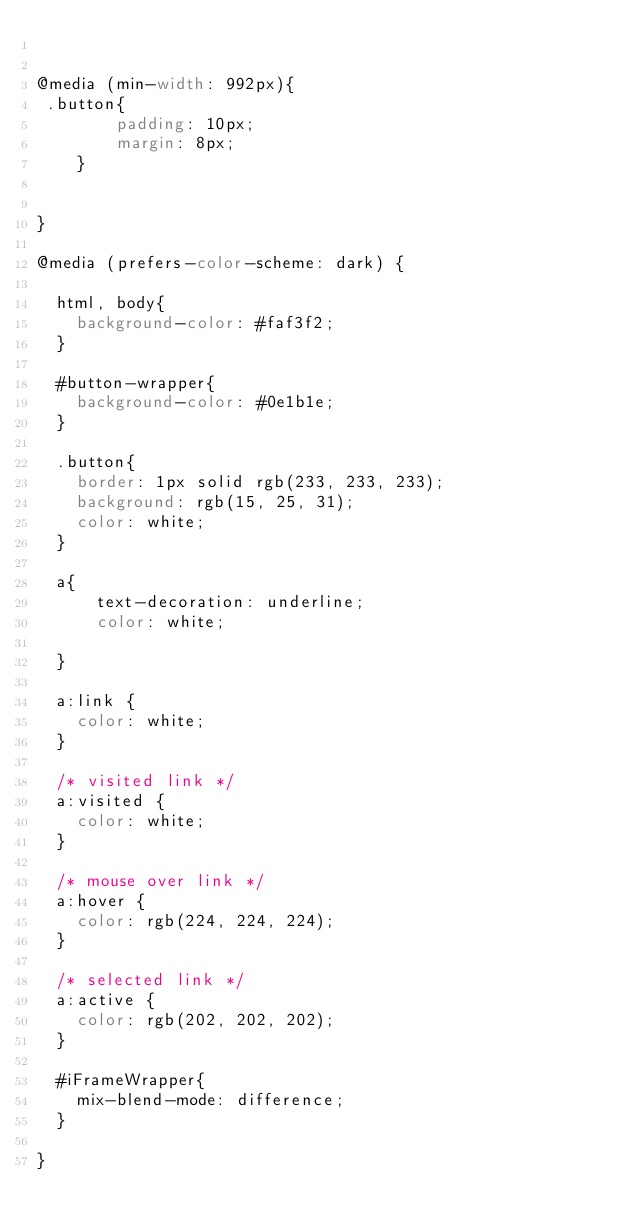<code> <loc_0><loc_0><loc_500><loc_500><_CSS_>

@media (min-width: 992px){
 .button{
		padding: 10px;
		margin: 8px;
	}


}

@media (prefers-color-scheme: dark) {

  html, body{
    background-color: #faf3f2;
  }

  #button-wrapper{
    background-color: #0e1b1e;
  }

  .button{
    border: 1px solid rgb(233, 233, 233);
    background: rgb(15, 25, 31);
	color: white;
  }

  a{
      text-decoration: underline;
	  color: white;

  }

  a:link {
    color: white;
  }

  /* visited link */
  a:visited {
    color: white;
  }

  /* mouse over link */
  a:hover {
    color: rgb(224, 224, 224);
  }

  /* selected link */
  a:active {
    color: rgb(202, 202, 202);
  }

  #iFrameWrapper{
	mix-blend-mode: difference;
  }

}
</code> 